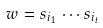Convert formula to latex. <formula><loc_0><loc_0><loc_500><loc_500>w = s _ { i _ { 1 } } \cdots s _ { i _ { t } }</formula> 